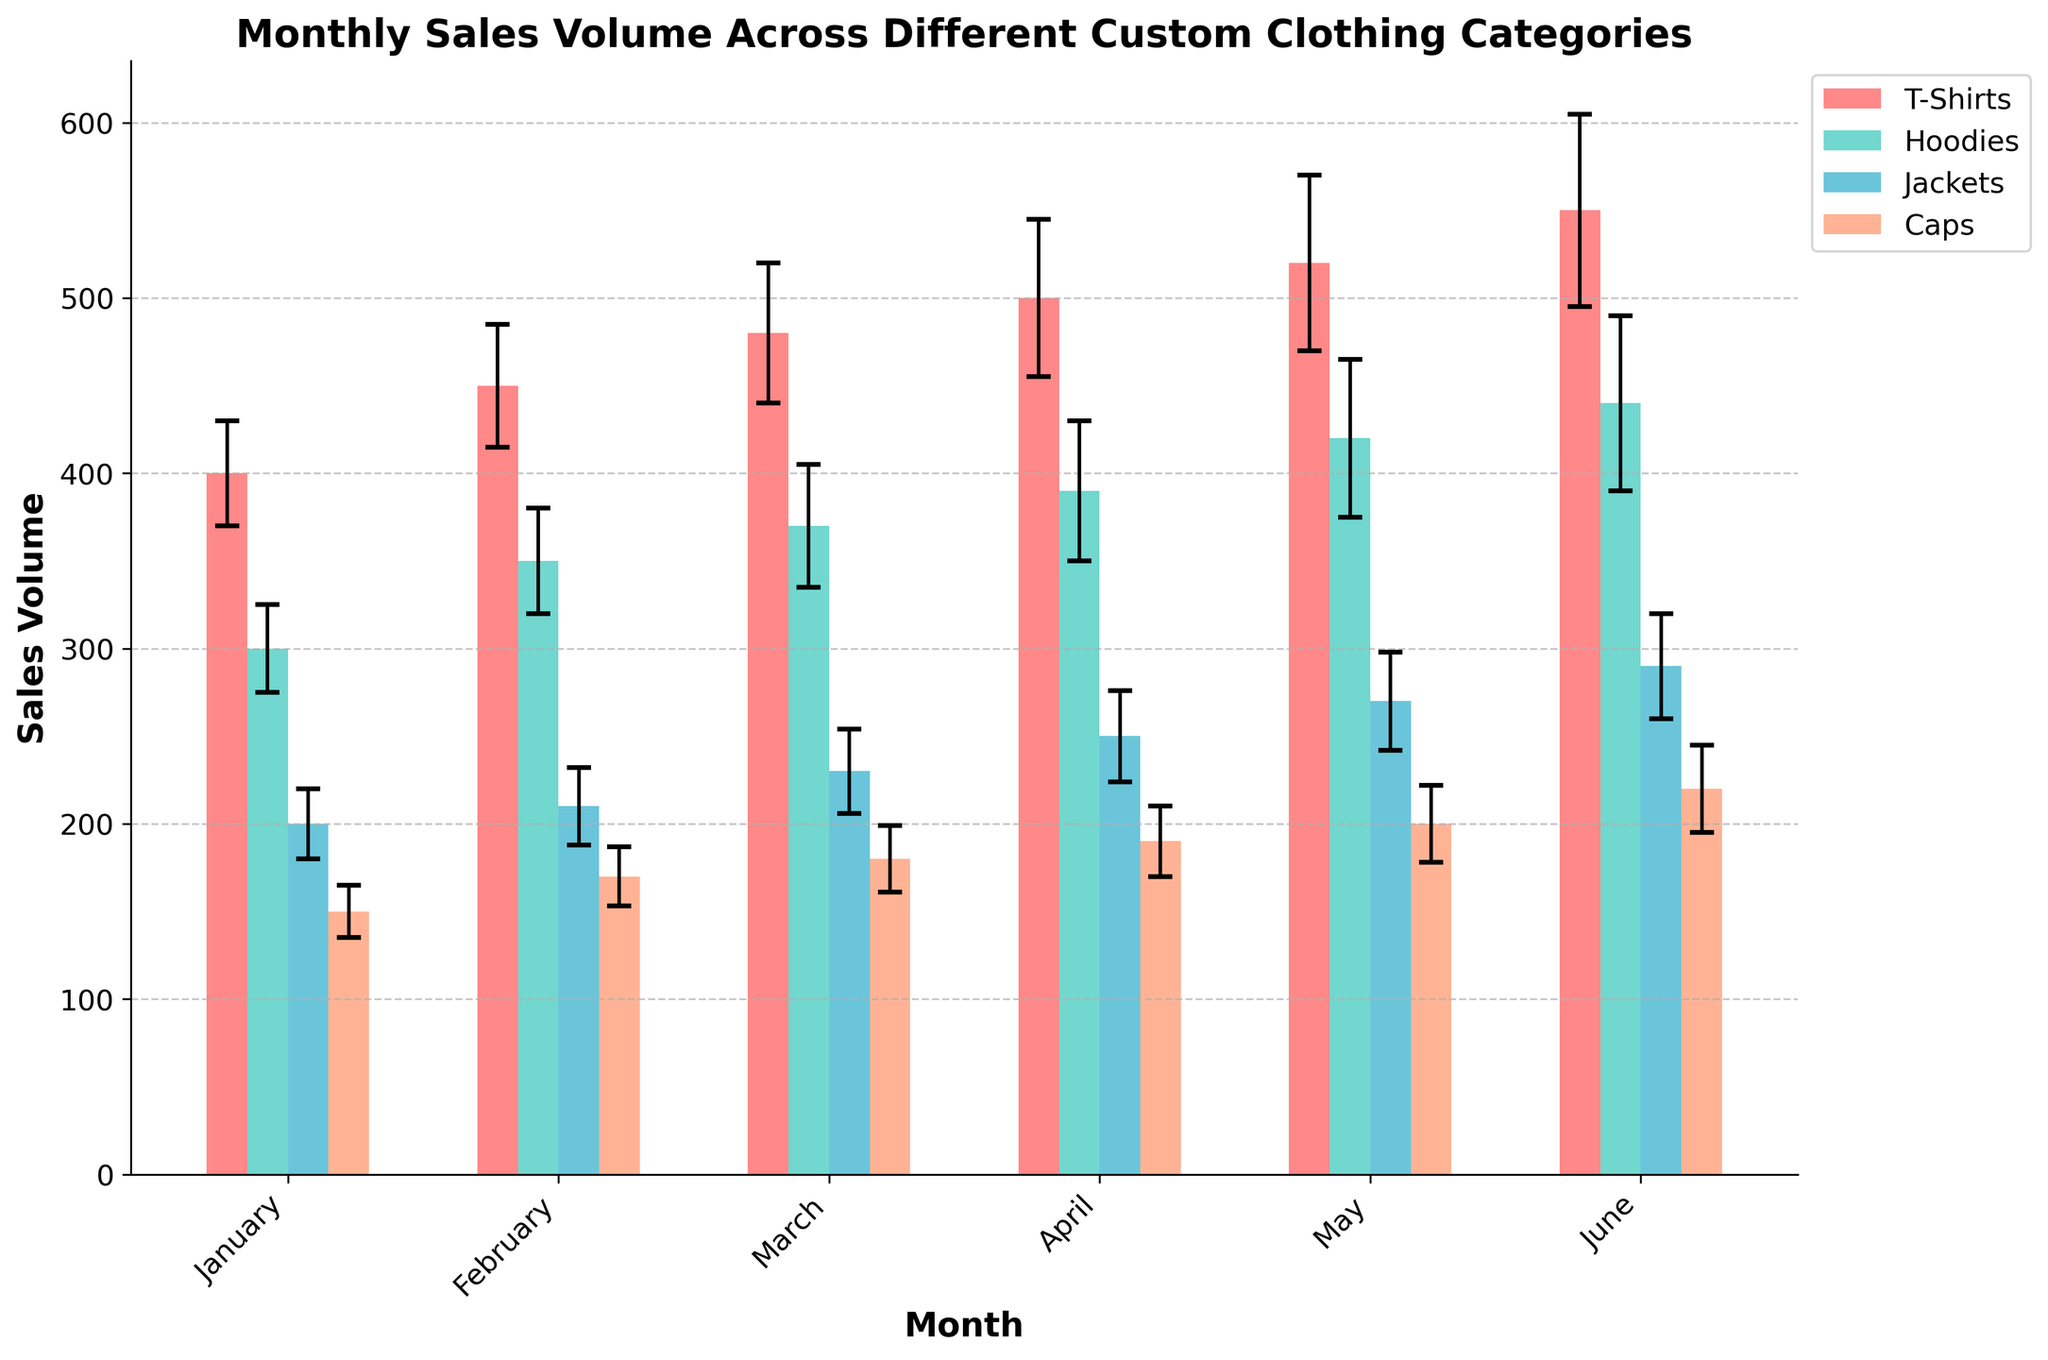What is the title of the bar chart? The title can be found at the top of the chart. It reads, "Monthly Sales Volume Across Different Custom Clothing Categories."
Answer: Monthly Sales Volume Across Different Custom Clothing Categories How many categories of custom clothing are presented in the chart? By counting the unique bars in the legend, we see there are four categories: T-Shirts, Hoodies, Jackets, and Caps.
Answer: 4 Which month has the highest sales volume for T-Shirts? Looking at the T-Shirts bars, the bar for June is the tallest, indicating the highest sales volume.
Answer: June What is the error margin for Caps in April? The Caps bar for April has an error bar extending up and down. The chart indicates this error margin is 20.
Answer: 20 What is the total sales volume for Jackets in January and February combined? The sales volumes for Jackets in January and February are 200 and 210, respectively. Summing these values gives 200 + 210 = 410.
Answer: 410 Which category shows the greatest increase in sales volume from January to June? By observing the height change from January to June for each category, T-Shirts show the greatest increase in height, indicating the largest sales increase.
Answer: T-Shirts How does the sales volume of Hoodies in May compare to that in April? The bar for Hoodies in May is higher than that in April, indicating an increase. Specifically, May's sales volume is 420 compared to April's 390.
Answer: May is higher What is the range of error margins for the category with the highest total sales volume in May? In May, T-Shirts, which have the highest total sales volume, have error margins ranging from 30 to 55. By focusing on T-Shirts in May specifically, the given error margin is 50.
Answer: 50 What is the difference in the sales volume of Caps between January and March? The sales volumes for Caps in January and March are 150 and 180, respectively. The difference is 180 - 150 = 30.
Answer: 30 Which two categories have the smallest difference in their sales volumes for any single month? By comparing the bars visually month by month, in February, Jackets and Caps are the closest, with sales volumes of 210 for Jackets and 170 for Caps. The difference is 210 - 170 = 40.
Answer: Jackets and Caps in February 